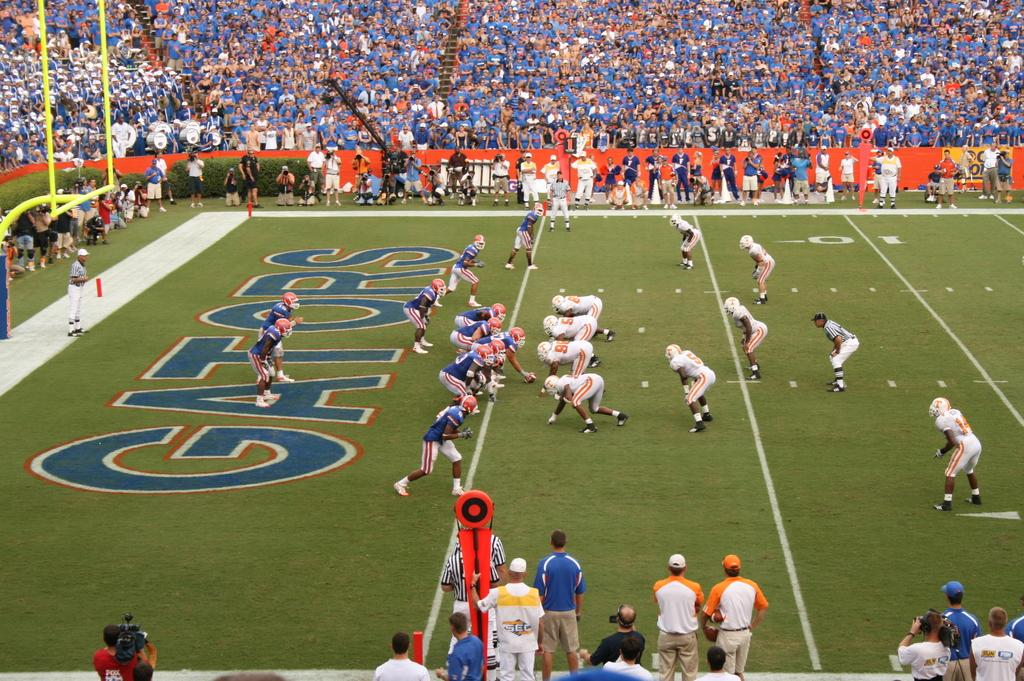What is happening in the foreground of the image? There are people on the ground in the image. What can be seen in the background of the image? There is a group of people and objects visible in the background of the image. What type of zebra is playing the note in the image? There is no zebra or note present in the image. 